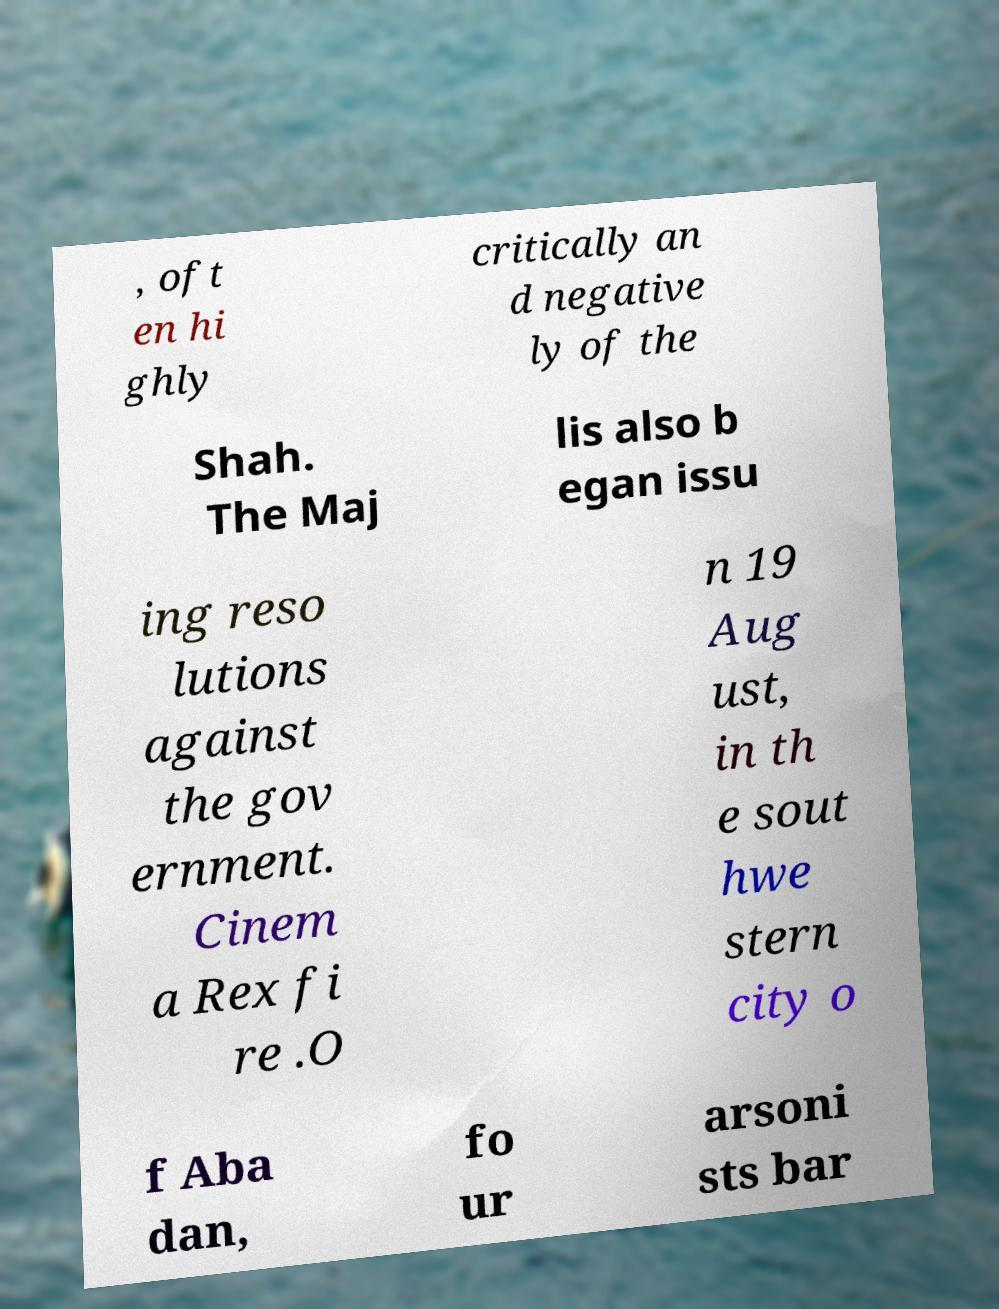I need the written content from this picture converted into text. Can you do that? , oft en hi ghly critically an d negative ly of the Shah. The Maj lis also b egan issu ing reso lutions against the gov ernment. Cinem a Rex fi re .O n 19 Aug ust, in th e sout hwe stern city o f Aba dan, fo ur arsoni sts bar 